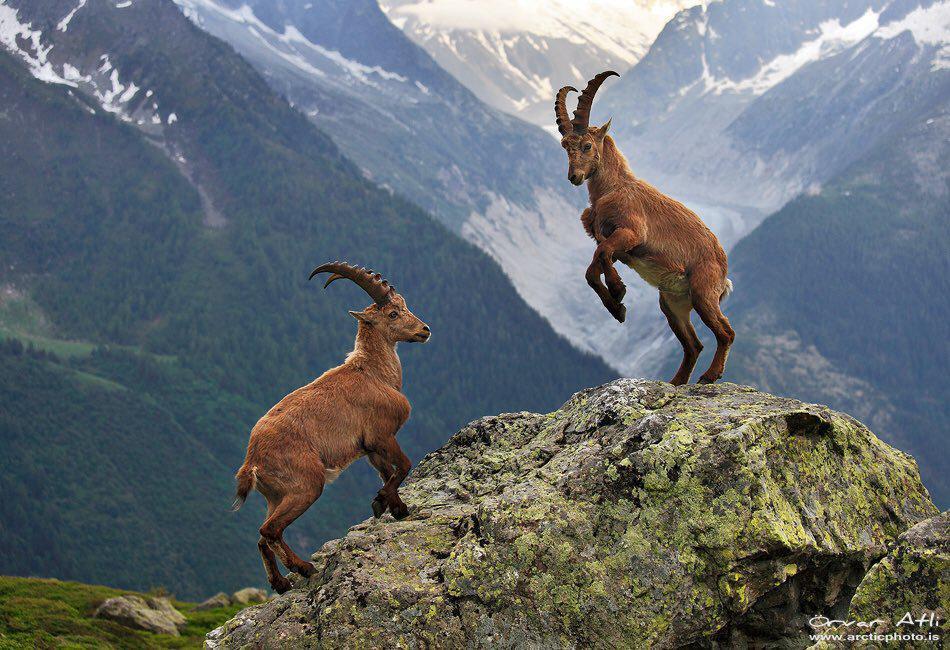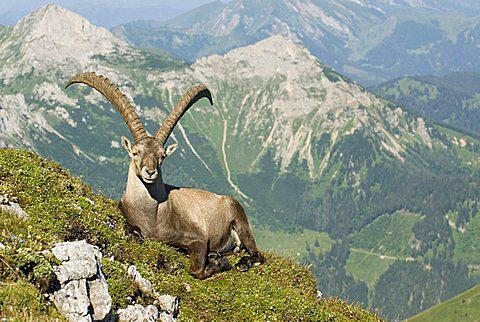The first image is the image on the left, the second image is the image on the right. Analyze the images presented: Is the assertion "One of the images shows a horned mountain goat laying in the grass with mountains behind it." valid? Answer yes or no. Yes. The first image is the image on the left, the second image is the image on the right. For the images displayed, is the sentence "An image shows exactly one long-horned animal, which is posed with legs tucked underneath." factually correct? Answer yes or no. Yes. 